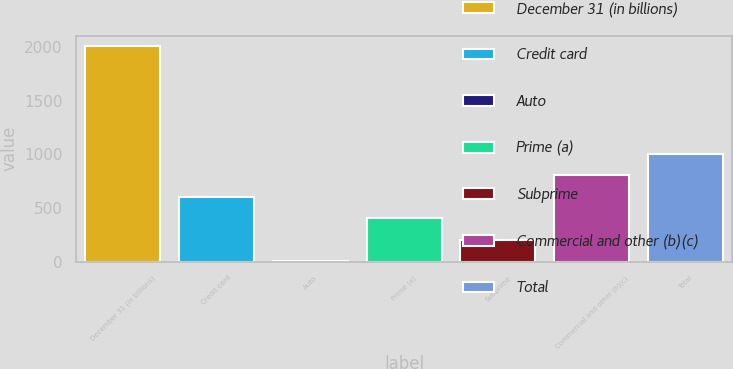Convert chart. <chart><loc_0><loc_0><loc_500><loc_500><bar_chart><fcel>December 31 (in billions)<fcel>Credit card<fcel>Auto<fcel>Prime (a)<fcel>Subprime<fcel>Commercial and other (b)(c)<fcel>Total<nl><fcel>2006<fcel>605.23<fcel>4.9<fcel>405.12<fcel>205.01<fcel>805.34<fcel>1005.45<nl></chart> 